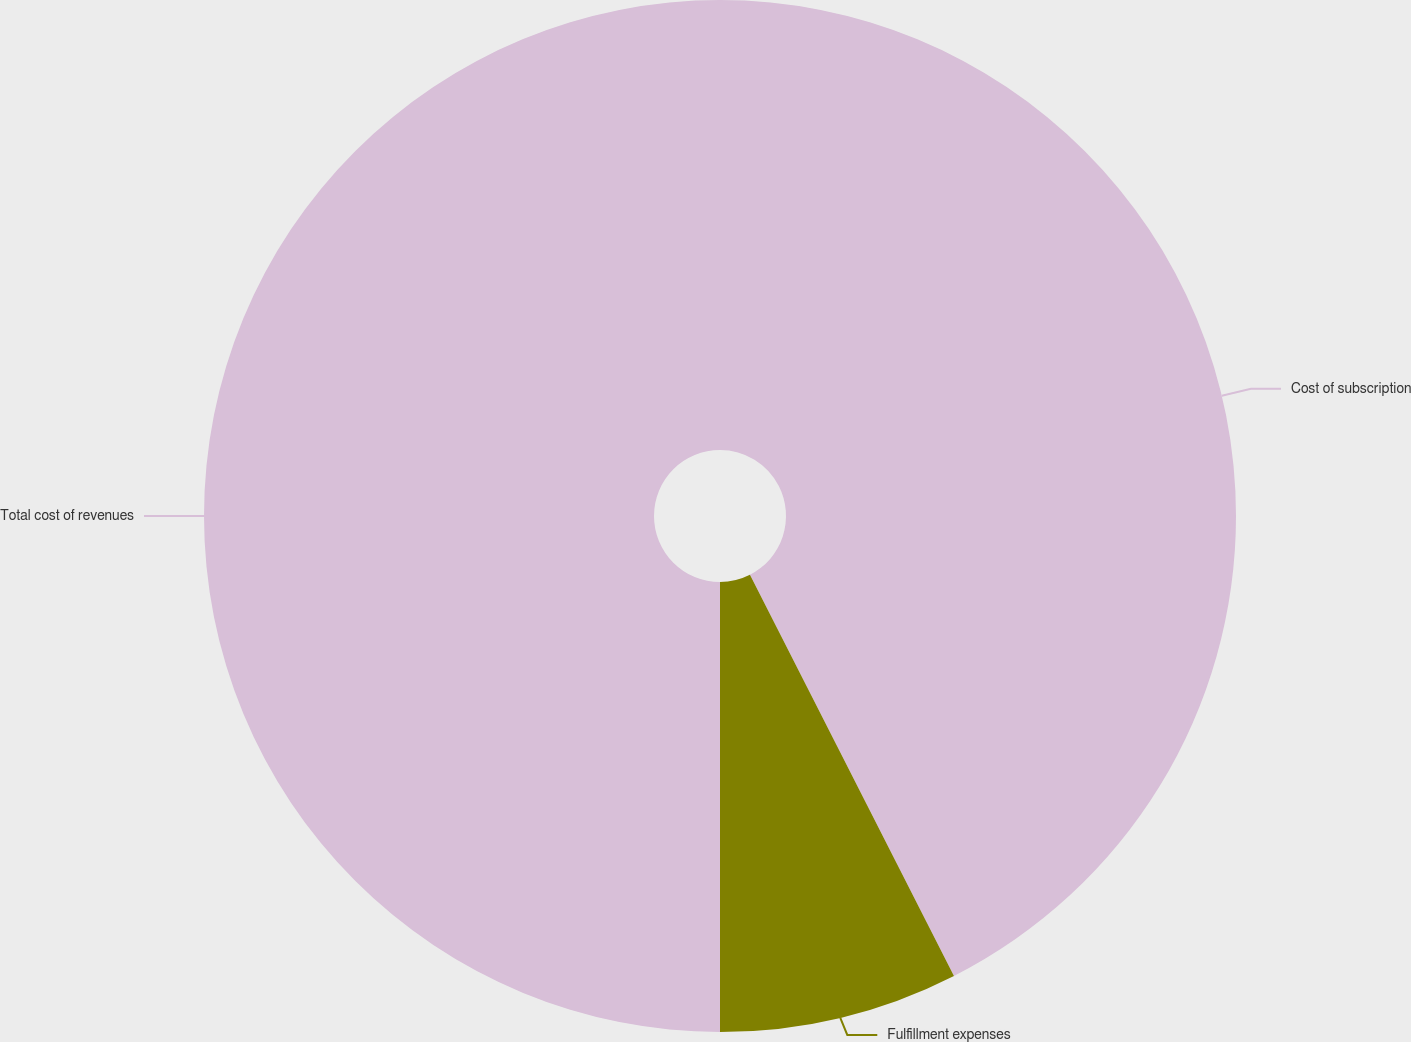<chart> <loc_0><loc_0><loc_500><loc_500><pie_chart><fcel>Cost of subscription<fcel>Fulfillment expenses<fcel>Total cost of revenues<nl><fcel>42.51%<fcel>7.49%<fcel>50.0%<nl></chart> 